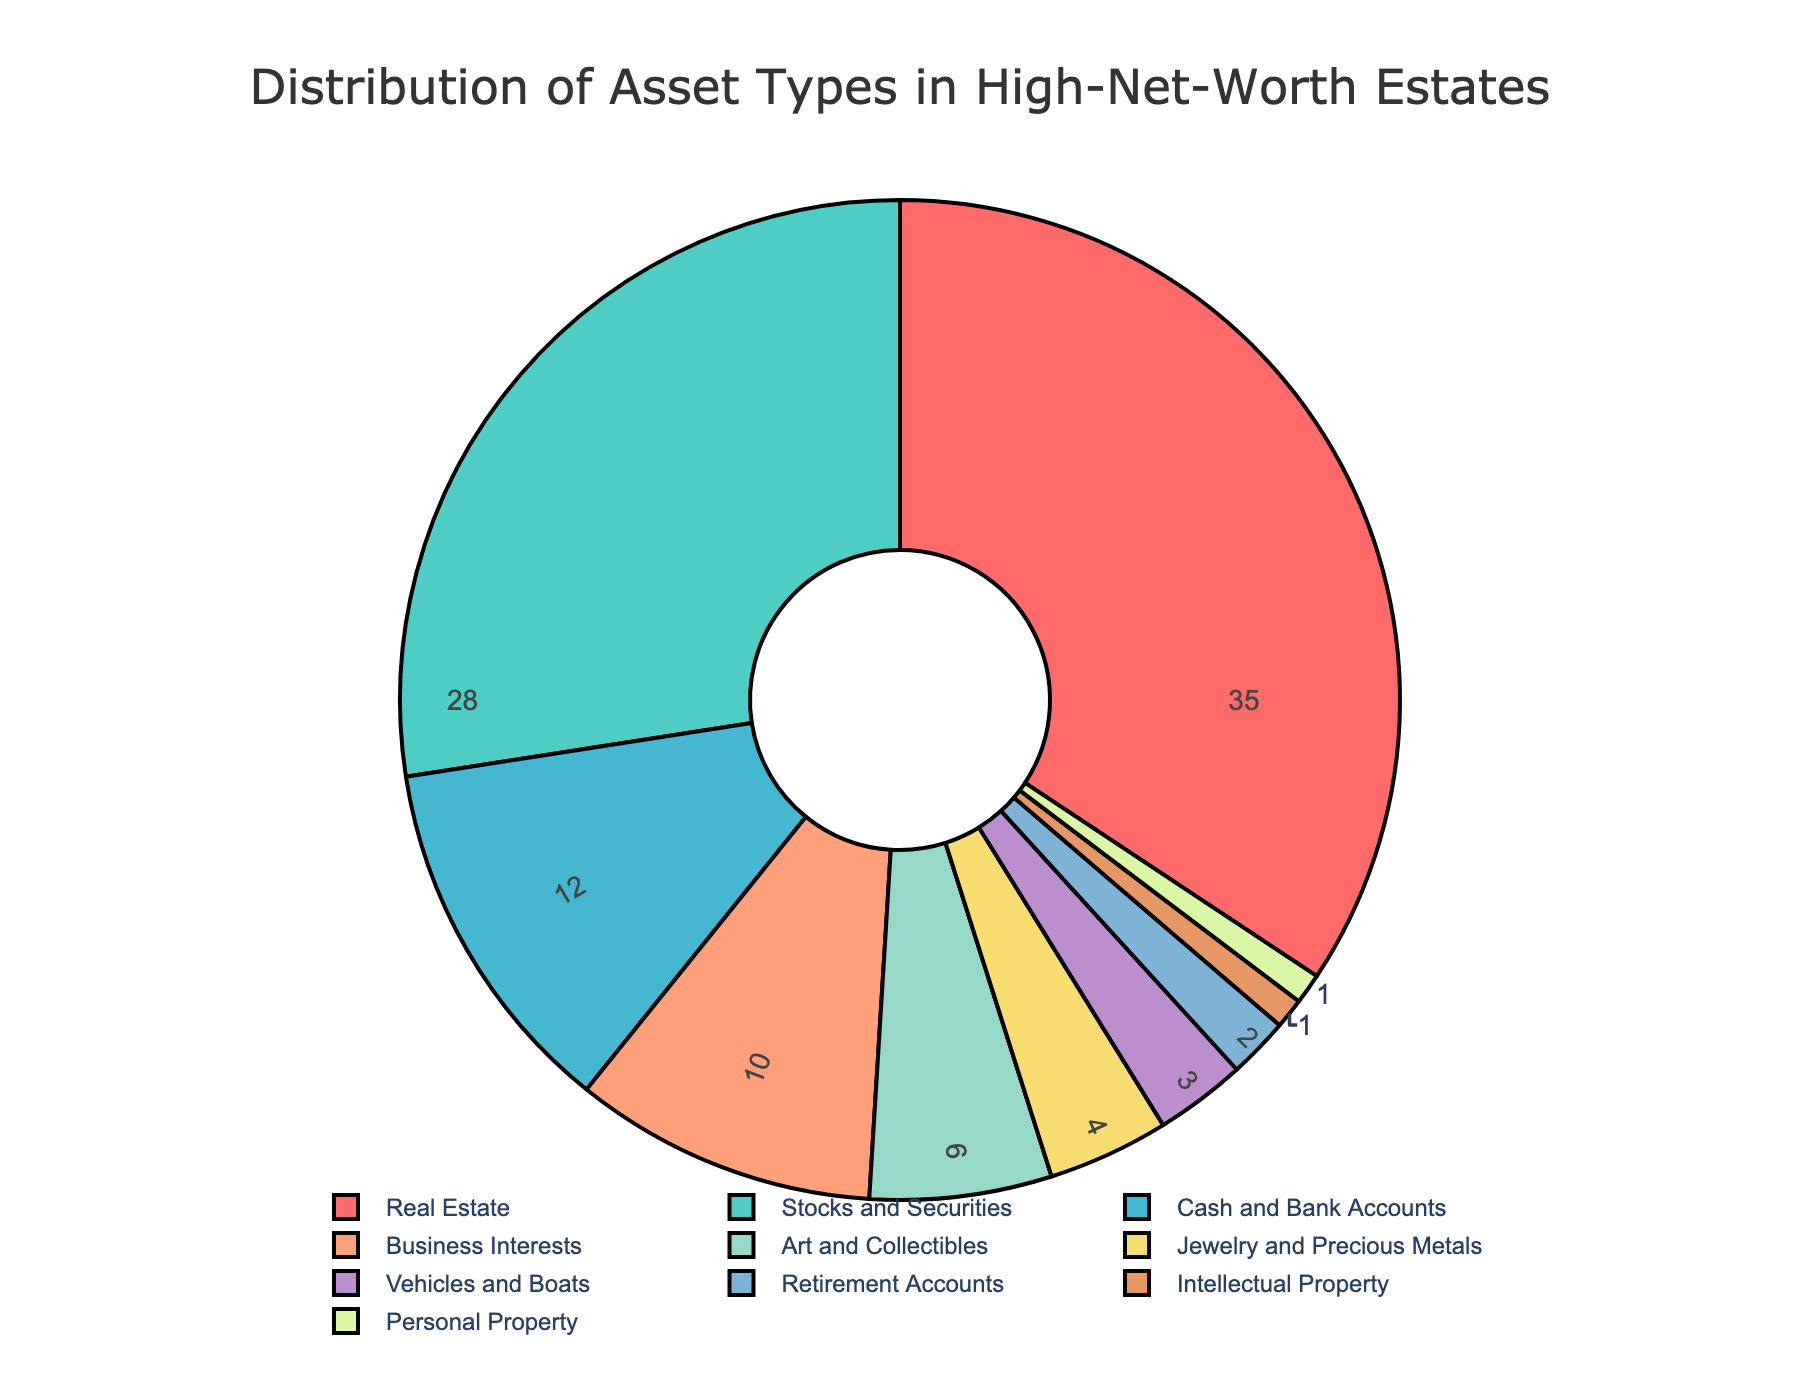Which asset type occupies the largest percentage in the estate distribution? The asset type with the largest percentage is determined by looking for the largest value in the chart. Real Estate has the highest percentage at 35%.
Answer: Real Estate What is the combined percentage of Stocks and Securities and Business Interests? Add the percentage of Stocks and Securities (28%) to that of Business Interests (10%). 28% + 10% = 38%.
Answer: 38% How many asset types have a percentage greater than 10%? Identify the asset types with percentages greater than 10%. The asset types are Real Estate (35%), Stocks and Securities (28%), Cash and Bank Accounts (12%), and Business Interests (10%). Only count those greater than 10%, i.e., Real Estate, Stocks and Securities, and Cash and Bank Accounts.
Answer: 3 Which asset type contributes the least to the estate's distribution? The asset type with the smallest percentage is identified as the one with the lowest value in the chart. Both Intellectual Property and Personal Property have the lowest value of 1%.
Answer: Intellectual Property and Personal Property What is the difference in percentage between Real Estate and Cash and Bank Accounts? Subtract the percentage of Cash and Bank Accounts (12%) from Real Estate (35%). 35% - 12% = 23%.
Answer: 23% Which asset type is represented by the blue color in the chart? Examine the color associated with each segment in the pie chart. The blue color corresponds to Stocks and Securities.
Answer: Stocks and Securities What is the sum of the percentages of Art and Collectibles, Vehicles and Boats, and Jewelry and Precious Metals? Add the percentages of Art and Collectibles (6%), Vehicles and Boats (3%), and Jewelry and Precious Metals (4%). 6% + 3% + 4% = 13%.
Answer: 13% Is the percentage of Stocks and Securities greater than twice the percentage of Cash and Bank Accounts? Calculate twice the percentage of Cash and Bank Accounts (12%). This is 2 x 12% = 24%. Compare it to the percentage of Stocks and Securities (28%). Since 28% is greater than 24%, the statement is true.
Answer: Yes What is the total of all the percentages in the chart? Sum all the percentages: 35% + 28% + 12% + 10% + 6% + 4% + 3% + 2% + 1% + 1% = 100%. All the percentages add up to 100%, as it is a pie chart representing the whole distribution.
Answer: 100% Which is greater: the sum of Jewelry and Precious Metals and Vehicles and Boats or the percentage of Cash and Bank Accounts? Calculate the sum of Jewelry and Precious Metals (4%) and Vehicles and Boats (3%). This is 4% + 3% = 7%. Compare this to the percentage of Cash and Bank Accounts (12%). Since 12% is greater than 7%, the percentage of Cash and Bank Accounts is greater.
Answer: Cash and Bank Accounts 